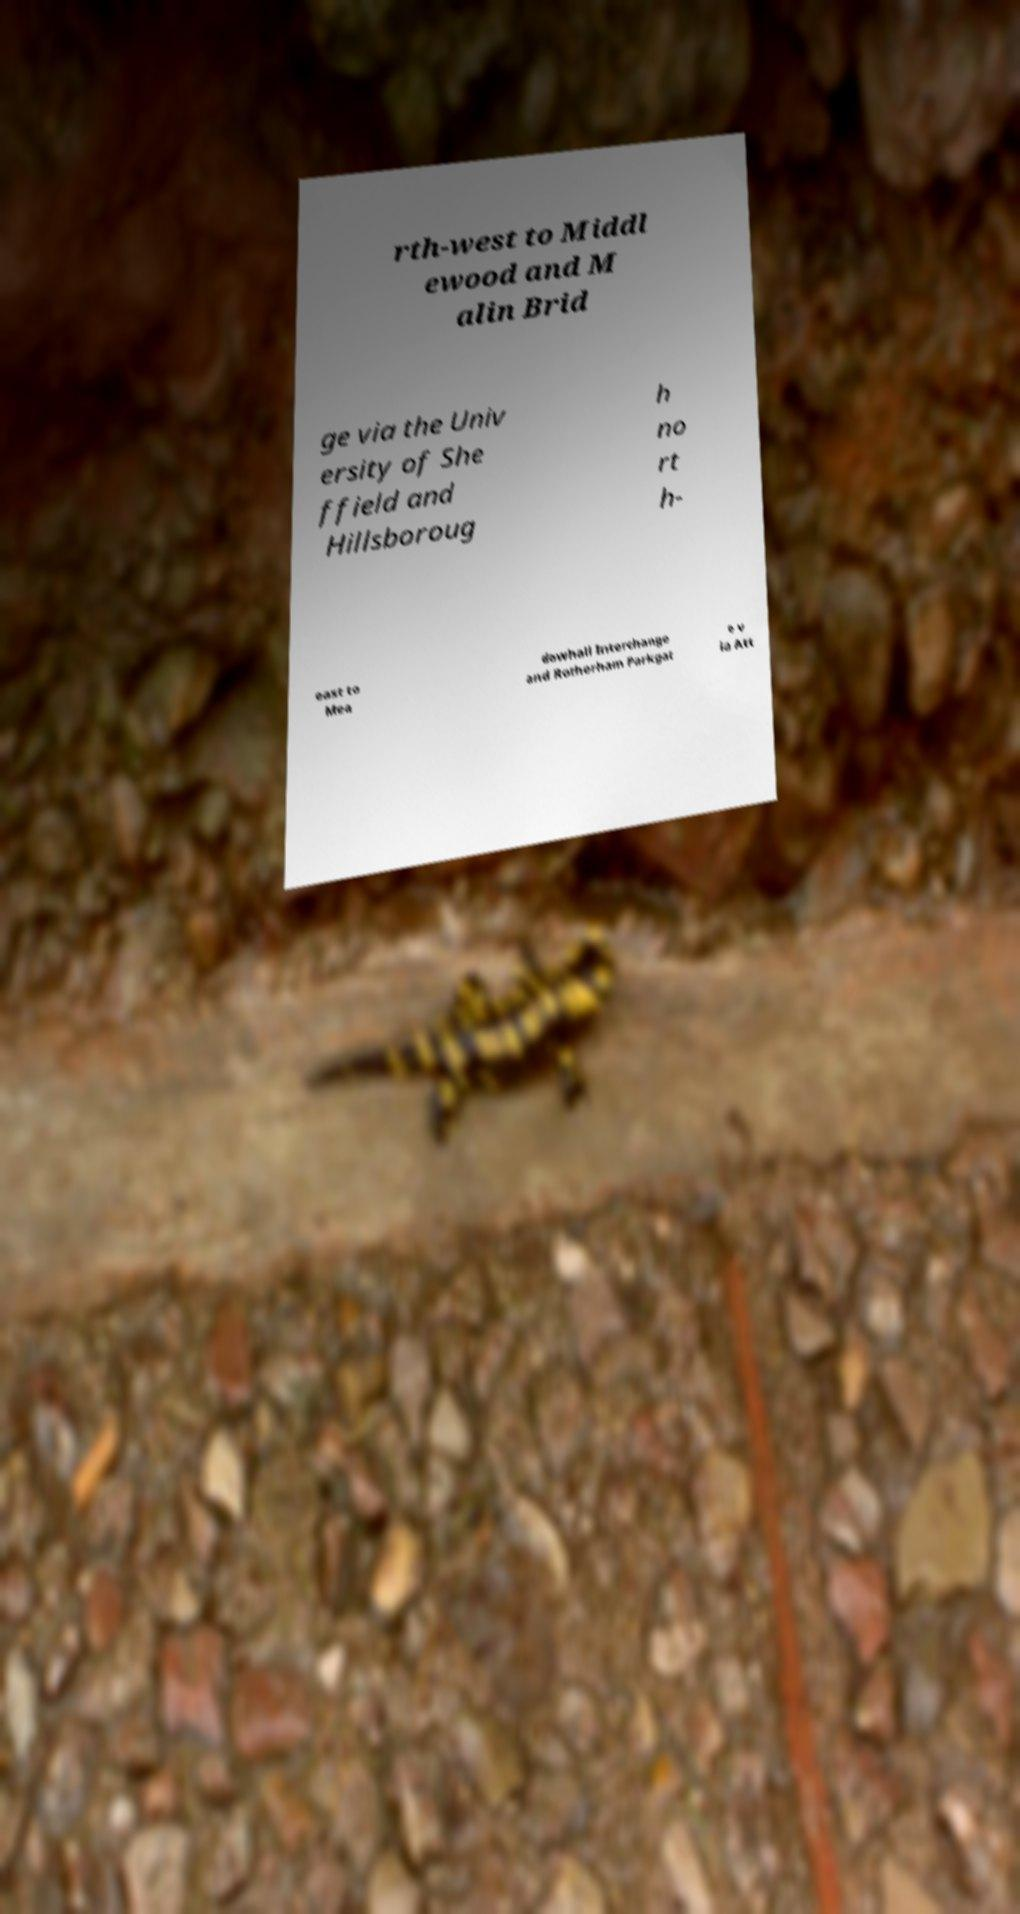Could you extract and type out the text from this image? rth-west to Middl ewood and M alin Brid ge via the Univ ersity of She ffield and Hillsboroug h no rt h- east to Mea dowhall Interchange and Rotherham Parkgat e v ia Att 